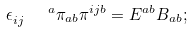<formula> <loc_0><loc_0><loc_500><loc_500>\epsilon _ { i j } ^ { \quad a } \pi _ { a b } \pi ^ { i j b } = E ^ { a b } B _ { a b } ;</formula> 